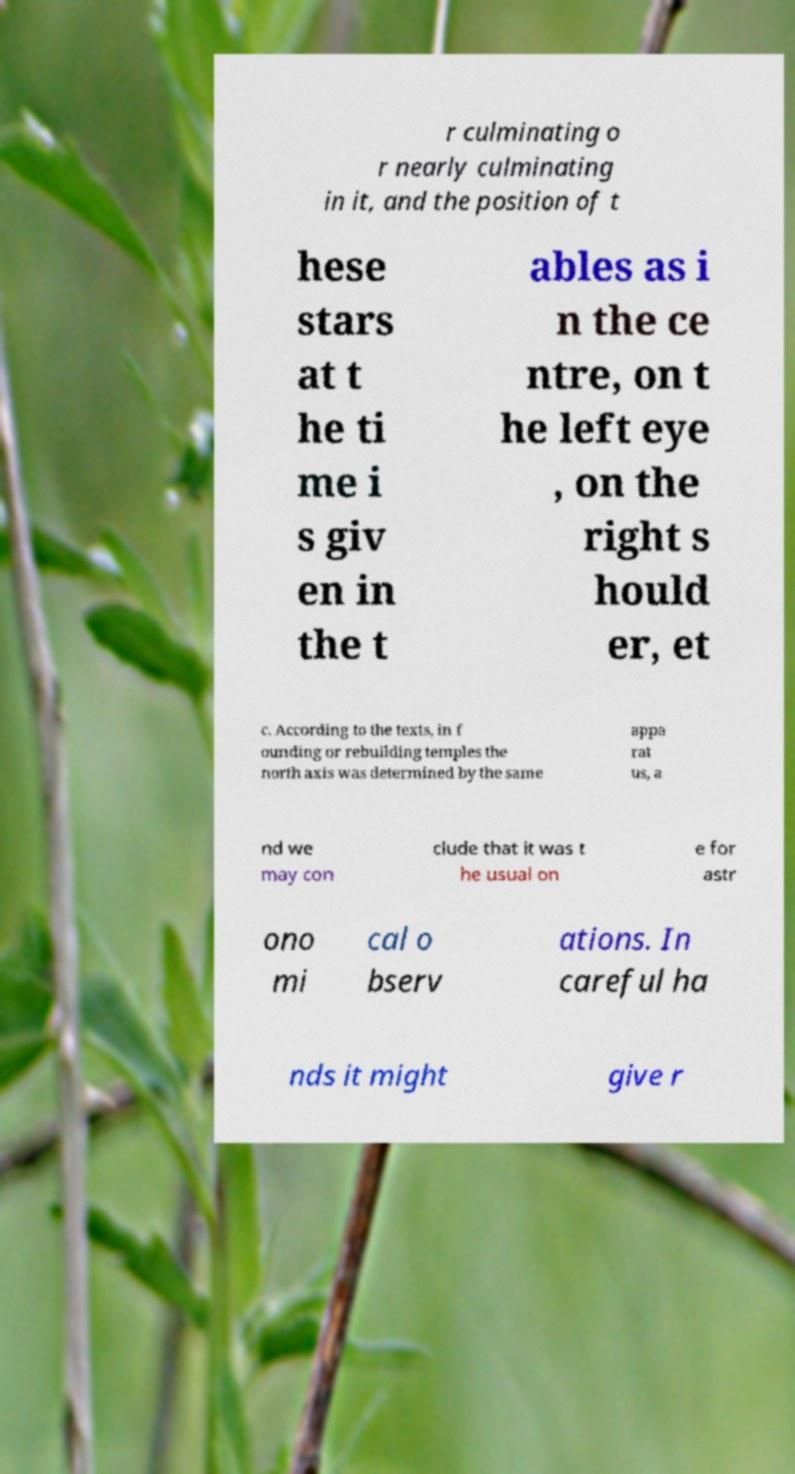Could you extract and type out the text from this image? r culminating o r nearly culminating in it, and the position of t hese stars at t he ti me i s giv en in the t ables as i n the ce ntre, on t he left eye , on the right s hould er, et c. According to the texts, in f ounding or rebuilding temples the north axis was determined by the same appa rat us, a nd we may con clude that it was t he usual on e for astr ono mi cal o bserv ations. In careful ha nds it might give r 